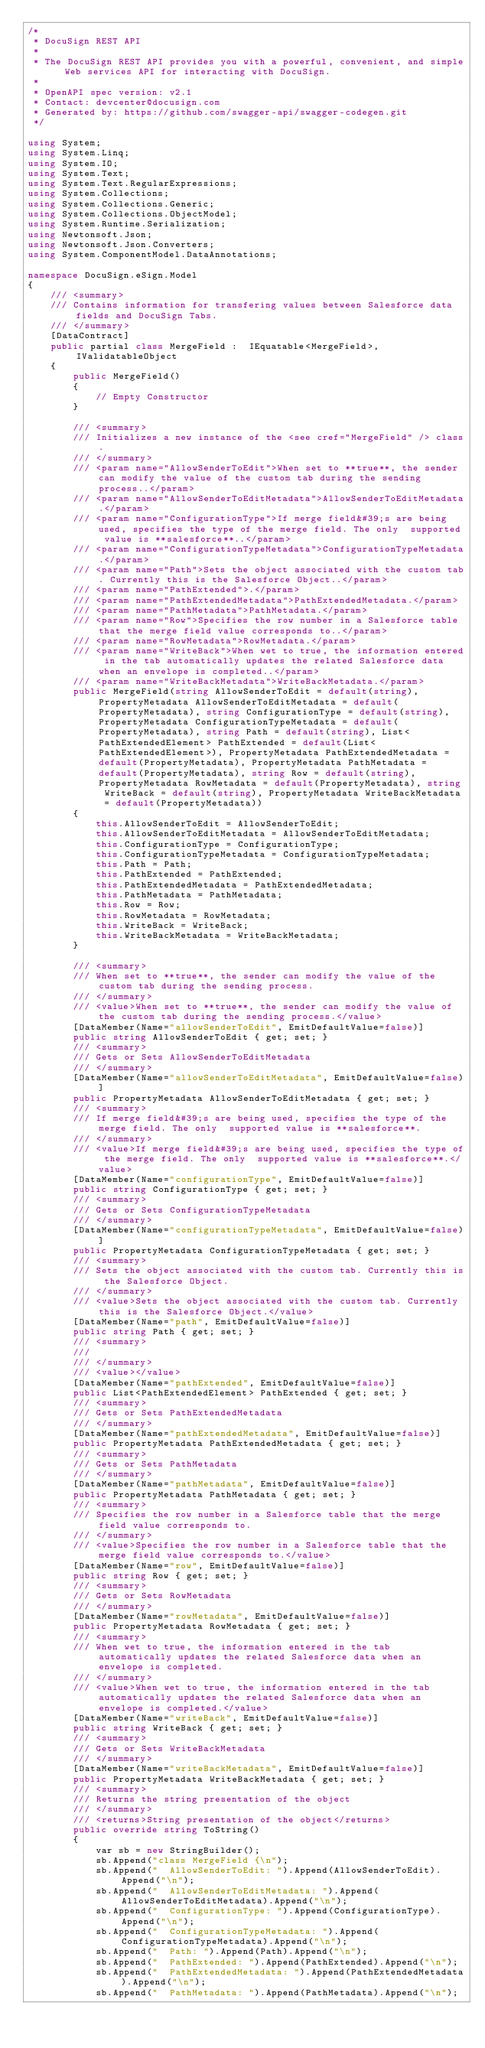<code> <loc_0><loc_0><loc_500><loc_500><_C#_>/* 
 * DocuSign REST API
 *
 * The DocuSign REST API provides you with a powerful, convenient, and simple Web services API for interacting with DocuSign.
 *
 * OpenAPI spec version: v2.1
 * Contact: devcenter@docusign.com
 * Generated by: https://github.com/swagger-api/swagger-codegen.git
 */

using System;
using System.Linq;
using System.IO;
using System.Text;
using System.Text.RegularExpressions;
using System.Collections;
using System.Collections.Generic;
using System.Collections.ObjectModel;
using System.Runtime.Serialization;
using Newtonsoft.Json;
using Newtonsoft.Json.Converters;
using System.ComponentModel.DataAnnotations;

namespace DocuSign.eSign.Model
{
    /// <summary>
    /// Contains information for transfering values between Salesforce data fields and DocuSign Tabs.
    /// </summary>
    [DataContract]
    public partial class MergeField :  IEquatable<MergeField>, IValidatableObject
    {
        public MergeField()
        {
            // Empty Constructor
        }

        /// <summary>
        /// Initializes a new instance of the <see cref="MergeField" /> class.
        /// </summary>
        /// <param name="AllowSenderToEdit">When set to **true**, the sender can modify the value of the custom tab during the sending process..</param>
        /// <param name="AllowSenderToEditMetadata">AllowSenderToEditMetadata.</param>
        /// <param name="ConfigurationType">If merge field&#39;s are being used, specifies the type of the merge field. The only  supported value is **salesforce**..</param>
        /// <param name="ConfigurationTypeMetadata">ConfigurationTypeMetadata.</param>
        /// <param name="Path">Sets the object associated with the custom tab. Currently this is the Salesforce Object..</param>
        /// <param name="PathExtended">.</param>
        /// <param name="PathExtendedMetadata">PathExtendedMetadata.</param>
        /// <param name="PathMetadata">PathMetadata.</param>
        /// <param name="Row">Specifies the row number in a Salesforce table that the merge field value corresponds to..</param>
        /// <param name="RowMetadata">RowMetadata.</param>
        /// <param name="WriteBack">When wet to true, the information entered in the tab automatically updates the related Salesforce data when an envelope is completed..</param>
        /// <param name="WriteBackMetadata">WriteBackMetadata.</param>
        public MergeField(string AllowSenderToEdit = default(string), PropertyMetadata AllowSenderToEditMetadata = default(PropertyMetadata), string ConfigurationType = default(string), PropertyMetadata ConfigurationTypeMetadata = default(PropertyMetadata), string Path = default(string), List<PathExtendedElement> PathExtended = default(List<PathExtendedElement>), PropertyMetadata PathExtendedMetadata = default(PropertyMetadata), PropertyMetadata PathMetadata = default(PropertyMetadata), string Row = default(string), PropertyMetadata RowMetadata = default(PropertyMetadata), string WriteBack = default(string), PropertyMetadata WriteBackMetadata = default(PropertyMetadata))
        {
            this.AllowSenderToEdit = AllowSenderToEdit;
            this.AllowSenderToEditMetadata = AllowSenderToEditMetadata;
            this.ConfigurationType = ConfigurationType;
            this.ConfigurationTypeMetadata = ConfigurationTypeMetadata;
            this.Path = Path;
            this.PathExtended = PathExtended;
            this.PathExtendedMetadata = PathExtendedMetadata;
            this.PathMetadata = PathMetadata;
            this.Row = Row;
            this.RowMetadata = RowMetadata;
            this.WriteBack = WriteBack;
            this.WriteBackMetadata = WriteBackMetadata;
        }
        
        /// <summary>
        /// When set to **true**, the sender can modify the value of the custom tab during the sending process.
        /// </summary>
        /// <value>When set to **true**, the sender can modify the value of the custom tab during the sending process.</value>
        [DataMember(Name="allowSenderToEdit", EmitDefaultValue=false)]
        public string AllowSenderToEdit { get; set; }
        /// <summary>
        /// Gets or Sets AllowSenderToEditMetadata
        /// </summary>
        [DataMember(Name="allowSenderToEditMetadata", EmitDefaultValue=false)]
        public PropertyMetadata AllowSenderToEditMetadata { get; set; }
        /// <summary>
        /// If merge field&#39;s are being used, specifies the type of the merge field. The only  supported value is **salesforce**.
        /// </summary>
        /// <value>If merge field&#39;s are being used, specifies the type of the merge field. The only  supported value is **salesforce**.</value>
        [DataMember(Name="configurationType", EmitDefaultValue=false)]
        public string ConfigurationType { get; set; }
        /// <summary>
        /// Gets or Sets ConfigurationTypeMetadata
        /// </summary>
        [DataMember(Name="configurationTypeMetadata", EmitDefaultValue=false)]
        public PropertyMetadata ConfigurationTypeMetadata { get; set; }
        /// <summary>
        /// Sets the object associated with the custom tab. Currently this is the Salesforce Object.
        /// </summary>
        /// <value>Sets the object associated with the custom tab. Currently this is the Salesforce Object.</value>
        [DataMember(Name="path", EmitDefaultValue=false)]
        public string Path { get; set; }
        /// <summary>
        /// 
        /// </summary>
        /// <value></value>
        [DataMember(Name="pathExtended", EmitDefaultValue=false)]
        public List<PathExtendedElement> PathExtended { get; set; }
        /// <summary>
        /// Gets or Sets PathExtendedMetadata
        /// </summary>
        [DataMember(Name="pathExtendedMetadata", EmitDefaultValue=false)]
        public PropertyMetadata PathExtendedMetadata { get; set; }
        /// <summary>
        /// Gets or Sets PathMetadata
        /// </summary>
        [DataMember(Name="pathMetadata", EmitDefaultValue=false)]
        public PropertyMetadata PathMetadata { get; set; }
        /// <summary>
        /// Specifies the row number in a Salesforce table that the merge field value corresponds to.
        /// </summary>
        /// <value>Specifies the row number in a Salesforce table that the merge field value corresponds to.</value>
        [DataMember(Name="row", EmitDefaultValue=false)]
        public string Row { get; set; }
        /// <summary>
        /// Gets or Sets RowMetadata
        /// </summary>
        [DataMember(Name="rowMetadata", EmitDefaultValue=false)]
        public PropertyMetadata RowMetadata { get; set; }
        /// <summary>
        /// When wet to true, the information entered in the tab automatically updates the related Salesforce data when an envelope is completed.
        /// </summary>
        /// <value>When wet to true, the information entered in the tab automatically updates the related Salesforce data when an envelope is completed.</value>
        [DataMember(Name="writeBack", EmitDefaultValue=false)]
        public string WriteBack { get; set; }
        /// <summary>
        /// Gets or Sets WriteBackMetadata
        /// </summary>
        [DataMember(Name="writeBackMetadata", EmitDefaultValue=false)]
        public PropertyMetadata WriteBackMetadata { get; set; }
        /// <summary>
        /// Returns the string presentation of the object
        /// </summary>
        /// <returns>String presentation of the object</returns>
        public override string ToString()
        {
            var sb = new StringBuilder();
            sb.Append("class MergeField {\n");
            sb.Append("  AllowSenderToEdit: ").Append(AllowSenderToEdit).Append("\n");
            sb.Append("  AllowSenderToEditMetadata: ").Append(AllowSenderToEditMetadata).Append("\n");
            sb.Append("  ConfigurationType: ").Append(ConfigurationType).Append("\n");
            sb.Append("  ConfigurationTypeMetadata: ").Append(ConfigurationTypeMetadata).Append("\n");
            sb.Append("  Path: ").Append(Path).Append("\n");
            sb.Append("  PathExtended: ").Append(PathExtended).Append("\n");
            sb.Append("  PathExtendedMetadata: ").Append(PathExtendedMetadata).Append("\n");
            sb.Append("  PathMetadata: ").Append(PathMetadata).Append("\n");</code> 